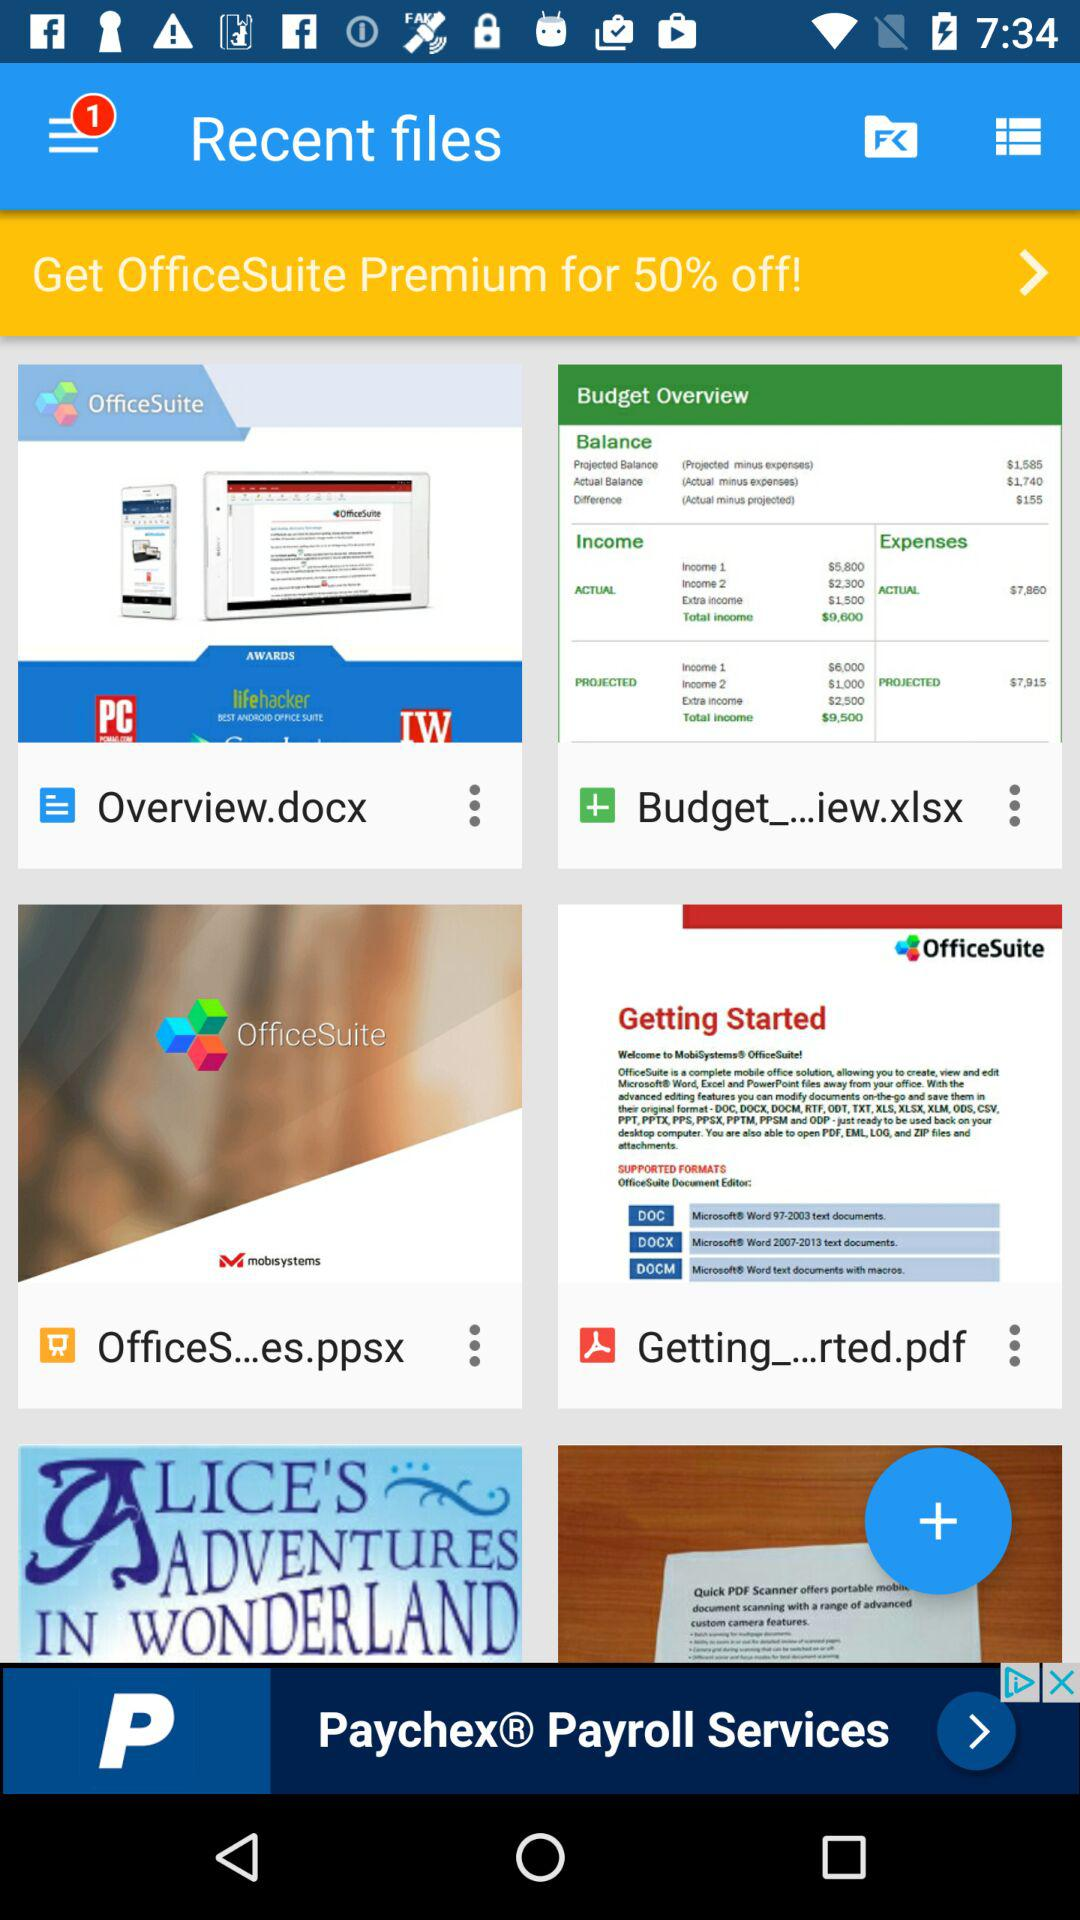How much of a discount can a busy office suite get? The discount is 50% off. 